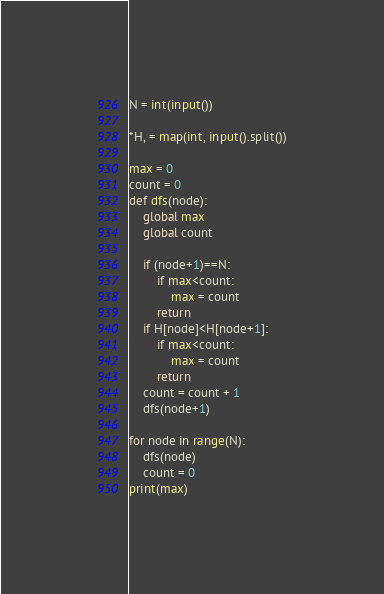Convert code to text. <code><loc_0><loc_0><loc_500><loc_500><_Python_>N = int(input())

*H, = map(int, input().split())

max = 0
count = 0
def dfs(node):
    global max
    global count

    if (node+1)==N:
        if max<count:
            max = count
        return 
    if H[node]<H[node+1]:
        if max<count:
            max = count
        return 
    count = count + 1
    dfs(node+1)

for node in range(N):
    dfs(node)
    count = 0
print(max)</code> 